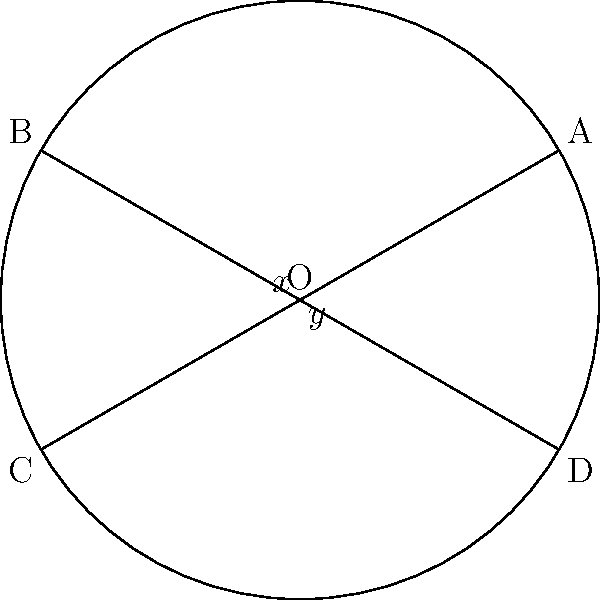In a circular coral reef formation, two divers observe intersecting patterns of coral growth resembling chords. The chords intersect as shown in the diagram, forming angles $x°$ and $y°$ at their intersection point. If $x = 35°$, what is the value of $y$? To solve this problem, we'll use the theorem about angles formed by intersecting chords in a circle:

1) When two chords intersect inside a circle, the measure of the angle formed is equal to half the sum of the measures of the arcs intercepted by the angle and its vertical angle.

2) In this case, we have two pairs of vertical angles: $x°$ and $y°$.

3) The sum of the measures of all angles around a point is 360°. Since $x°$ and $y°$ are vertical angles, we know that:
   
   $x° + x° + y° + y° = 360°$
   $2x° + 2y° = 360°$

4) We're given that $x = 35°$. Let's substitute this:
   
   $2(35°) + 2y° = 360°$
   $70° + 2y° = 360°$

5) Solve for $y$:
   
   $2y° = 360° - 70°$
   $2y° = 290°$
   $y° = 145°$

Therefore, the value of $y$ is 145°.
Answer: $145°$ 